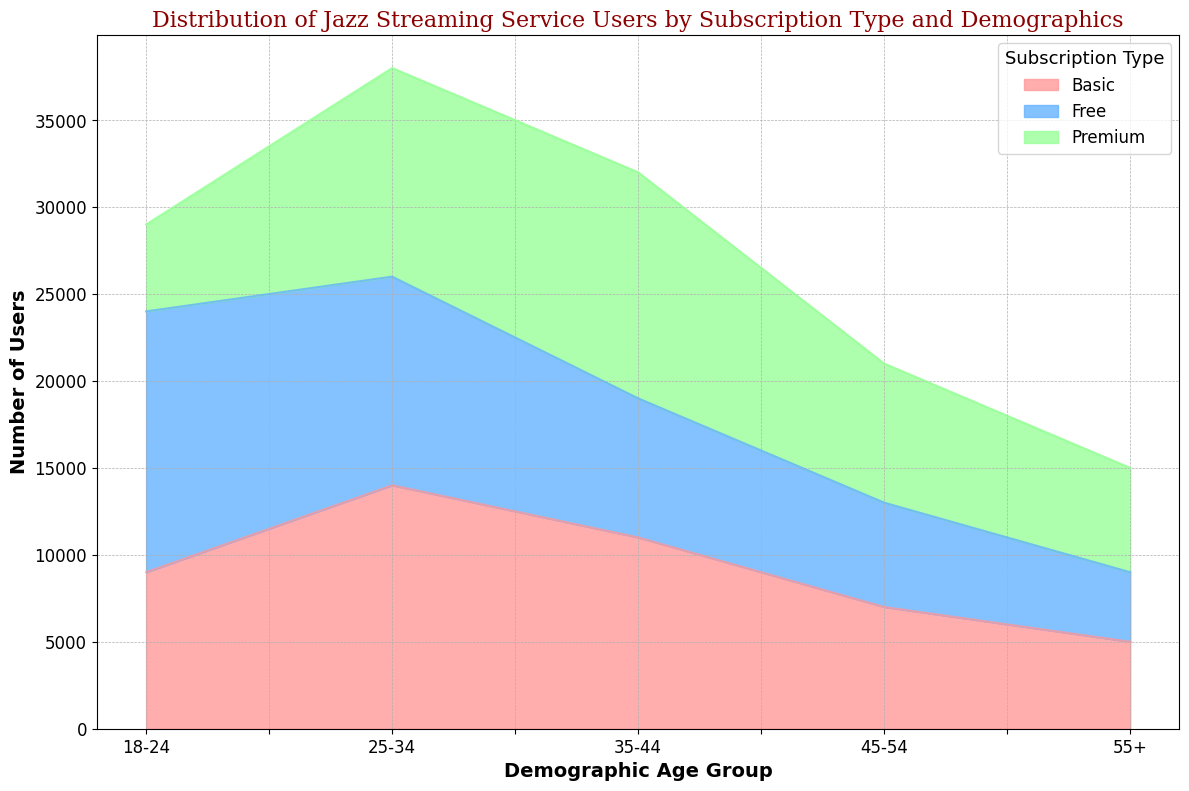What is the demographic group with the highest number of users for the Premium subscription? To determine the demographic group with the highest number of Premium users, look at the heights of the green segments on the chart. The 35-44 age group has the highest green region.
Answer: 35-44 Which subscription type has the least number of users in the 55+ age group? To find this, check the bottom-most segment (Free), the middle segment (Basic), and the top segment (Premium) for the 55+ age group. The smallest visual segment is the Free subscription.
Answer: Free What is the total number of users in the 25-34 age group across all subscription types? Sum the number of users from the Free, Basic, and Premium subscriptions for the 25-34 age group (12000 + 14000 + 12000).
Answer: 38000 Compare the number of users in the 18-24 age group for the Free and Basic subscriptions. Which group has more users and by how much? Look at the heights of the red (Free) and blue (Basic) segments for the 18-24 age group. The Free subscription has 15000 users, and Basic has 9000 users. Subtract 9000 from 15000.
Answer: Free by 6000 How does the total number of users in the 45-54 age group compare to that in the 35-44 age group? Sum the number of users from all subscription types for both age groups and compare. For 45-54: (6000 + 7000 + 8000) = 21000. For 35-44: (8000 + 11000 + 13000) = 32000. 32000 is greater than 21000.
Answer: 35-44 has more users What is the total number of Free and Basic users combined in the 55+ age group? Add up the Free and Basic users in the 55+ category (4000 + 5000).
Answer: 9000 In the 25-34 age group, is the number of Premium users greater than the number of Free users? Compare the heights of the Premium and Free segments in the 25-34 category. Premium has 12000 users, and Free has 12000 users. Both are equal.
Answer: No, they are equal 